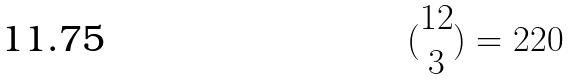Convert formula to latex. <formula><loc_0><loc_0><loc_500><loc_500>( \begin{matrix} 1 2 \\ 3 \end{matrix} ) = 2 2 0</formula> 